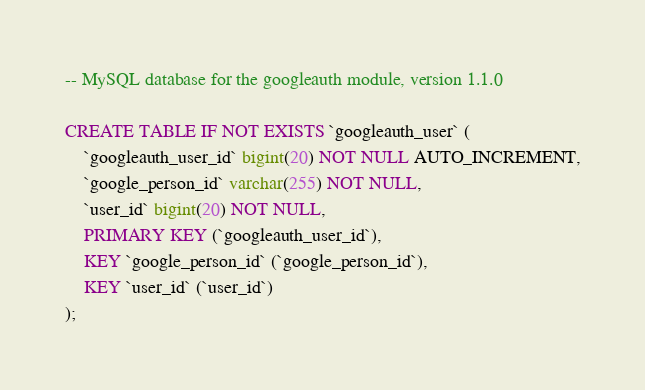Convert code to text. <code><loc_0><loc_0><loc_500><loc_500><_SQL_>
-- MySQL database for the googleauth module, version 1.1.0

CREATE TABLE IF NOT EXISTS `googleauth_user` (
    `googleauth_user_id` bigint(20) NOT NULL AUTO_INCREMENT,
    `google_person_id` varchar(255) NOT NULL,
    `user_id` bigint(20) NOT NULL,
    PRIMARY KEY (`googleauth_user_id`),
    KEY `google_person_id` (`google_person_id`),
    KEY `user_id` (`user_id`)
);
</code> 